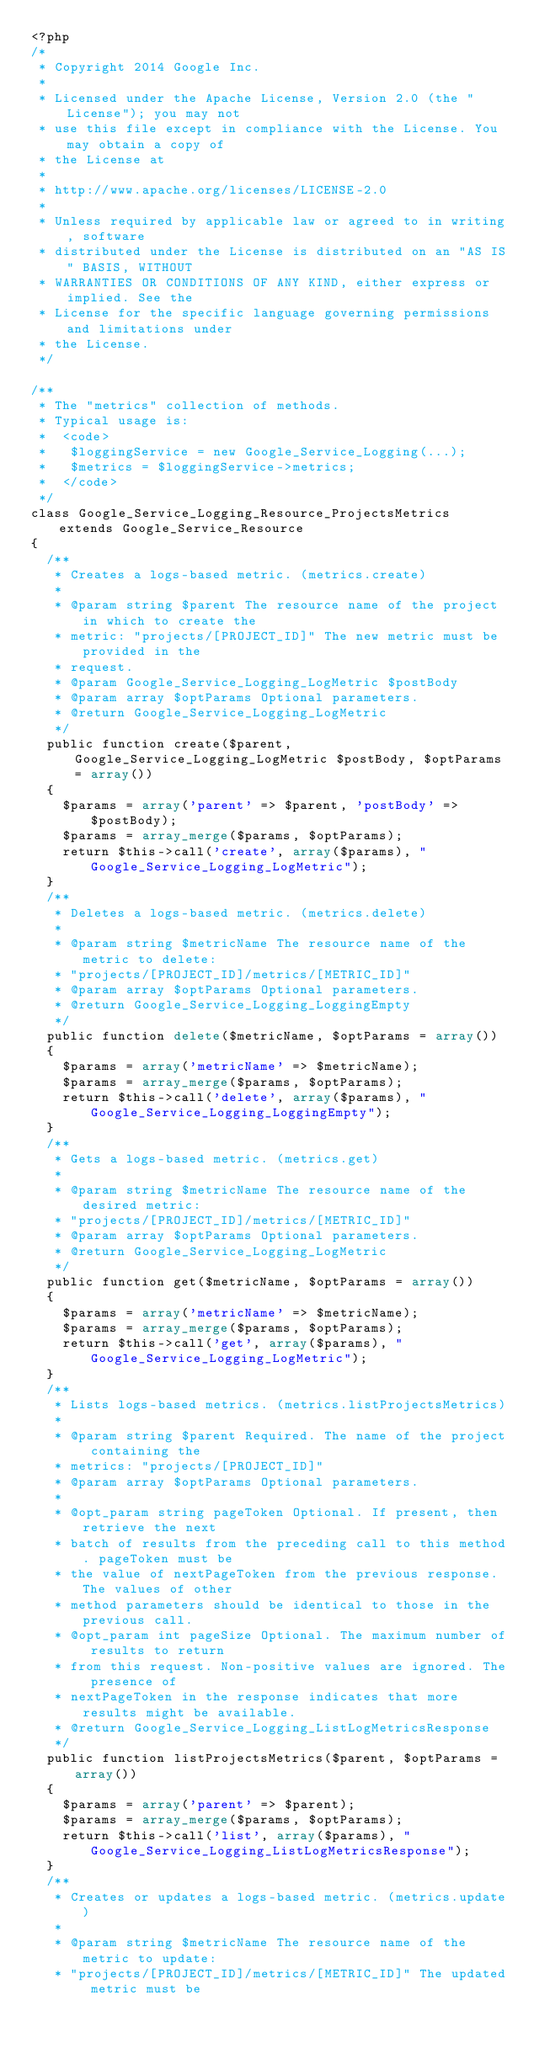Convert code to text. <code><loc_0><loc_0><loc_500><loc_500><_PHP_><?php
/*
 * Copyright 2014 Google Inc.
 *
 * Licensed under the Apache License, Version 2.0 (the "License"); you may not
 * use this file except in compliance with the License. You may obtain a copy of
 * the License at
 *
 * http://www.apache.org/licenses/LICENSE-2.0
 *
 * Unless required by applicable law or agreed to in writing, software
 * distributed under the License is distributed on an "AS IS" BASIS, WITHOUT
 * WARRANTIES OR CONDITIONS OF ANY KIND, either express or implied. See the
 * License for the specific language governing permissions and limitations under
 * the License.
 */

/**
 * The "metrics" collection of methods.
 * Typical usage is:
 *  <code>
 *   $loggingService = new Google_Service_Logging(...);
 *   $metrics = $loggingService->metrics;
 *  </code>
 */
class Google_Service_Logging_Resource_ProjectsMetrics extends Google_Service_Resource
{
  /**
   * Creates a logs-based metric. (metrics.create)
   *
   * @param string $parent The resource name of the project in which to create the
   * metric: "projects/[PROJECT_ID]" The new metric must be provided in the
   * request.
   * @param Google_Service_Logging_LogMetric $postBody
   * @param array $optParams Optional parameters.
   * @return Google_Service_Logging_LogMetric
   */
  public function create($parent, Google_Service_Logging_LogMetric $postBody, $optParams = array())
  {
    $params = array('parent' => $parent, 'postBody' => $postBody);
    $params = array_merge($params, $optParams);
    return $this->call('create', array($params), "Google_Service_Logging_LogMetric");
  }
  /**
   * Deletes a logs-based metric. (metrics.delete)
   *
   * @param string $metricName The resource name of the metric to delete:
   * "projects/[PROJECT_ID]/metrics/[METRIC_ID]"
   * @param array $optParams Optional parameters.
   * @return Google_Service_Logging_LoggingEmpty
   */
  public function delete($metricName, $optParams = array())
  {
    $params = array('metricName' => $metricName);
    $params = array_merge($params, $optParams);
    return $this->call('delete', array($params), "Google_Service_Logging_LoggingEmpty");
  }
  /**
   * Gets a logs-based metric. (metrics.get)
   *
   * @param string $metricName The resource name of the desired metric:
   * "projects/[PROJECT_ID]/metrics/[METRIC_ID]"
   * @param array $optParams Optional parameters.
   * @return Google_Service_Logging_LogMetric
   */
  public function get($metricName, $optParams = array())
  {
    $params = array('metricName' => $metricName);
    $params = array_merge($params, $optParams);
    return $this->call('get', array($params), "Google_Service_Logging_LogMetric");
  }
  /**
   * Lists logs-based metrics. (metrics.listProjectsMetrics)
   *
   * @param string $parent Required. The name of the project containing the
   * metrics: "projects/[PROJECT_ID]"
   * @param array $optParams Optional parameters.
   *
   * @opt_param string pageToken Optional. If present, then retrieve the next
   * batch of results from the preceding call to this method. pageToken must be
   * the value of nextPageToken from the previous response. The values of other
   * method parameters should be identical to those in the previous call.
   * @opt_param int pageSize Optional. The maximum number of results to return
   * from this request. Non-positive values are ignored. The presence of
   * nextPageToken in the response indicates that more results might be available.
   * @return Google_Service_Logging_ListLogMetricsResponse
   */
  public function listProjectsMetrics($parent, $optParams = array())
  {
    $params = array('parent' => $parent);
    $params = array_merge($params, $optParams);
    return $this->call('list', array($params), "Google_Service_Logging_ListLogMetricsResponse");
  }
  /**
   * Creates or updates a logs-based metric. (metrics.update)
   *
   * @param string $metricName The resource name of the metric to update:
   * "projects/[PROJECT_ID]/metrics/[METRIC_ID]" The updated metric must be</code> 